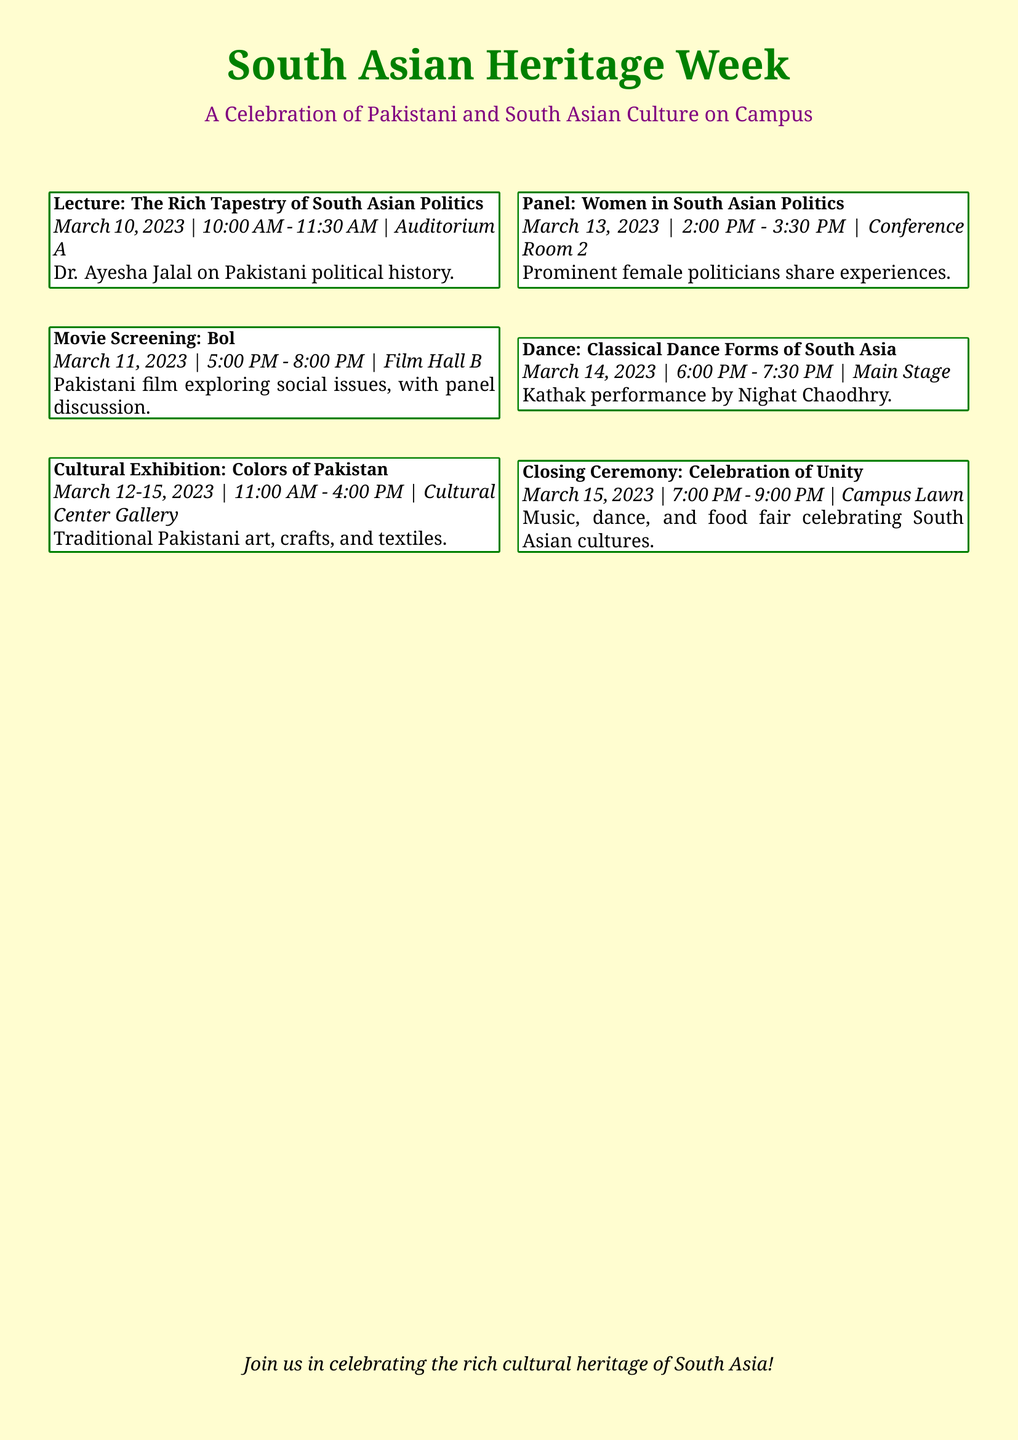what is the date of the lecture on South Asian politics? The lecture on South Asian politics is scheduled for March 10, 2023.
Answer: March 10, 2023 who is the speaker at the lecture? The speaker at the lecture is Dr. Ayesha Jalal.
Answer: Dr. Ayesha Jalal how long is the movie screening of Bol? The movie screening of Bol lasts from 5:00 PM to 8:00 PM, which is 3 hours.
Answer: 3 hours where will the cultural exhibition take place? The cultural exhibition titled "Colors of Pakistan" will take place at the Cultural Center Gallery.
Answer: Cultural Center Gallery when is the panel on Women in South Asian Politics scheduled? The panel is scheduled for March 13, 2023, from 2:00 PM to 3:30 PM.
Answer: March 13, 2023 how many days will the cultural exhibition be open? The cultural exhibition will be open from March 12 to March 15, which is 4 days.
Answer: 4 days what type of performance will be showcased on March 14? The type of performance showcased on March 14 is Classical Dance Forms of South Asia.
Answer: Classical Dance Forms of South Asia what event is scheduled for the closing ceremony? The closing ceremony is titled "Celebration of Unity."
Answer: Celebration of Unity what will the closing ceremony feature? The closing ceremony will feature music, dance, and a food fair.
Answer: music, dance, and food fair 